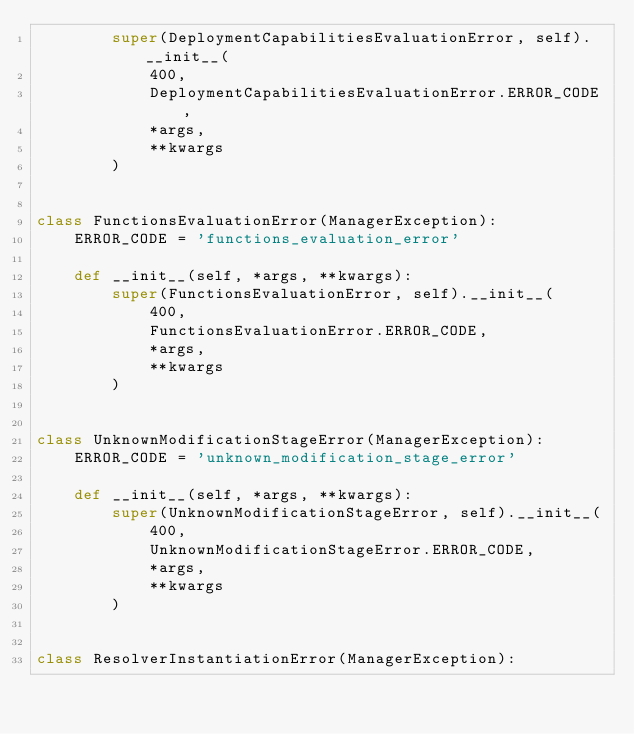Convert code to text. <code><loc_0><loc_0><loc_500><loc_500><_Python_>        super(DeploymentCapabilitiesEvaluationError, self).__init__(
            400,
            DeploymentCapabilitiesEvaluationError.ERROR_CODE,
            *args,
            **kwargs
        )


class FunctionsEvaluationError(ManagerException):
    ERROR_CODE = 'functions_evaluation_error'

    def __init__(self, *args, **kwargs):
        super(FunctionsEvaluationError, self).__init__(
            400,
            FunctionsEvaluationError.ERROR_CODE,
            *args,
            **kwargs
        )


class UnknownModificationStageError(ManagerException):
    ERROR_CODE = 'unknown_modification_stage_error'

    def __init__(self, *args, **kwargs):
        super(UnknownModificationStageError, self).__init__(
            400,
            UnknownModificationStageError.ERROR_CODE,
            *args,
            **kwargs
        )


class ResolverInstantiationError(ManagerException):</code> 